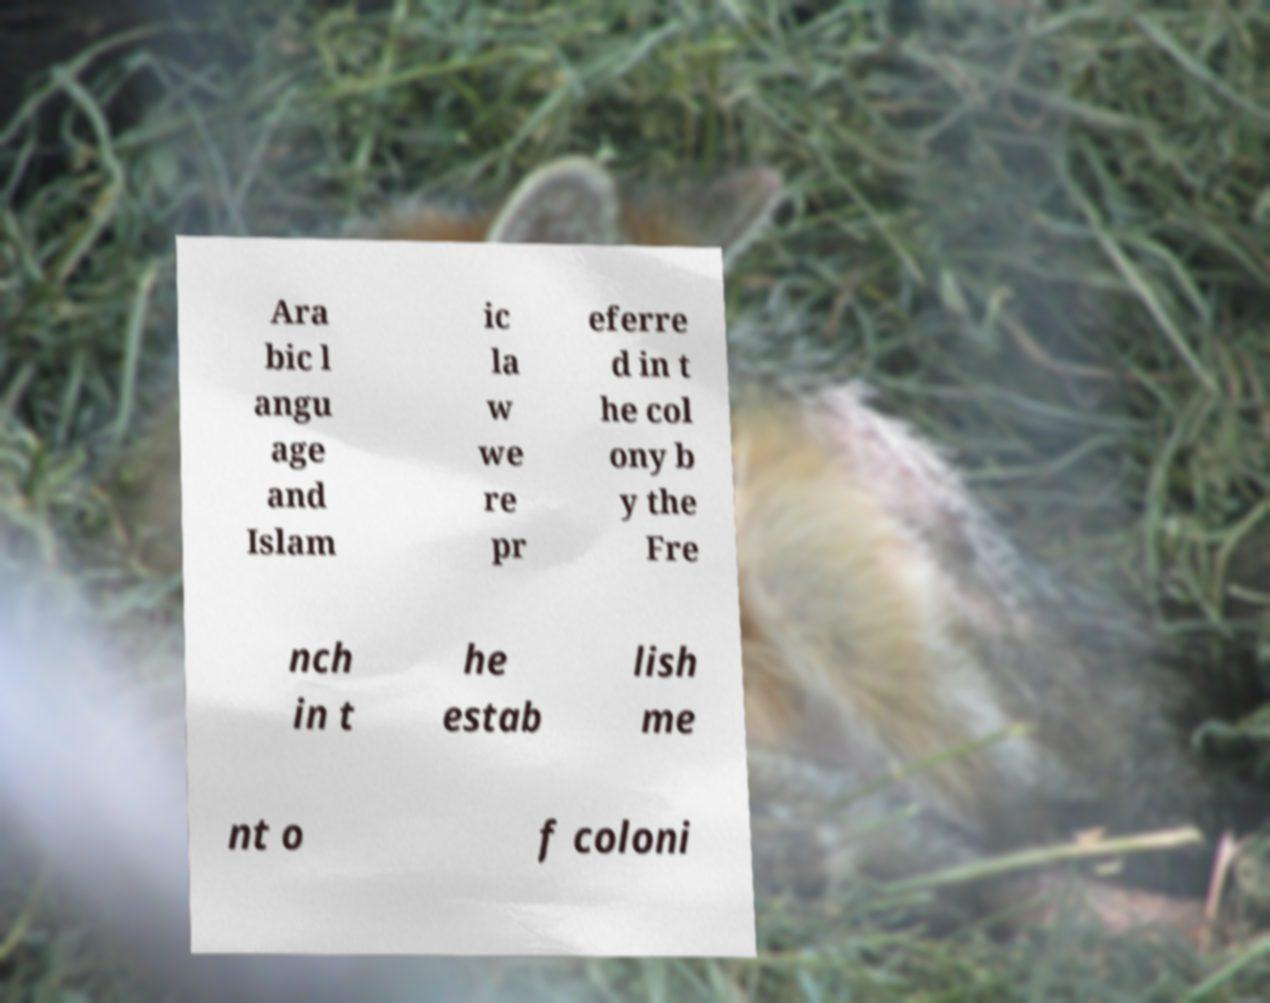Could you assist in decoding the text presented in this image and type it out clearly? Ara bic l angu age and Islam ic la w we re pr eferre d in t he col ony b y the Fre nch in t he estab lish me nt o f coloni 